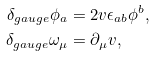Convert formula to latex. <formula><loc_0><loc_0><loc_500><loc_500>\delta _ { g a u g e } \phi _ { a } & = 2 v \epsilon _ { a b } \phi ^ { b } , \\ \delta _ { g a u g e } \omega _ { \mu } & = \partial _ { \mu } v ,</formula> 